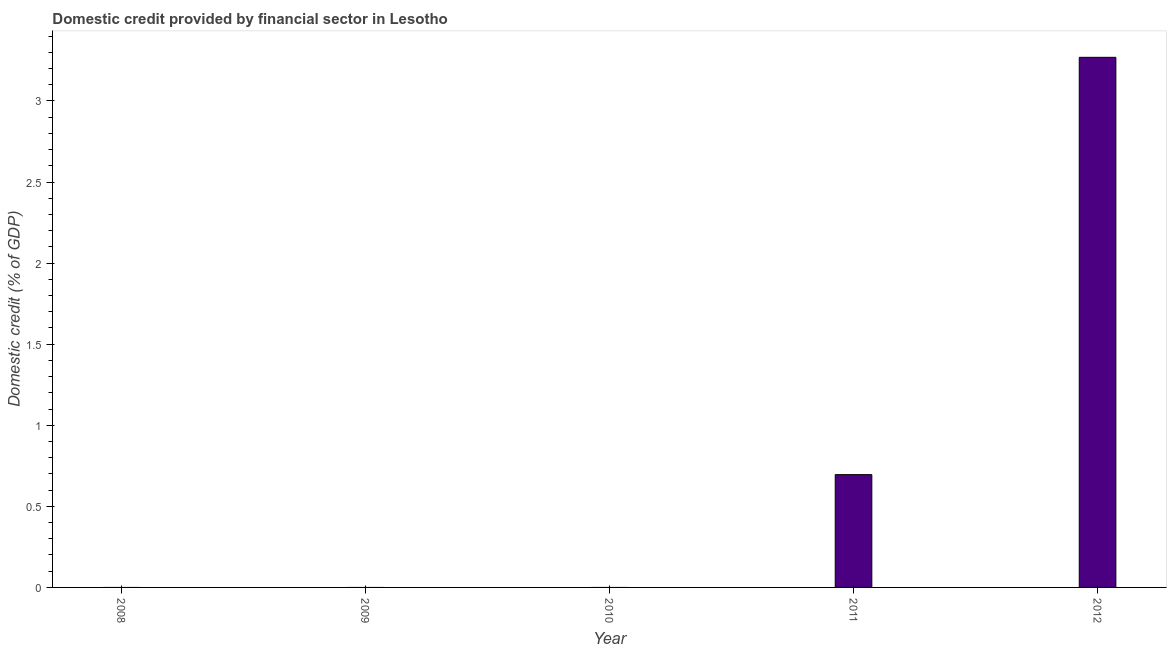Does the graph contain any zero values?
Give a very brief answer. Yes. What is the title of the graph?
Offer a very short reply. Domestic credit provided by financial sector in Lesotho. What is the label or title of the Y-axis?
Provide a short and direct response. Domestic credit (% of GDP). What is the domestic credit provided by financial sector in 2012?
Your answer should be very brief. 3.27. Across all years, what is the maximum domestic credit provided by financial sector?
Make the answer very short. 3.27. Across all years, what is the minimum domestic credit provided by financial sector?
Offer a terse response. 0. In which year was the domestic credit provided by financial sector maximum?
Offer a terse response. 2012. What is the sum of the domestic credit provided by financial sector?
Provide a succinct answer. 3.96. What is the average domestic credit provided by financial sector per year?
Your response must be concise. 0.79. What is the ratio of the domestic credit provided by financial sector in 2011 to that in 2012?
Make the answer very short. 0.21. Is the domestic credit provided by financial sector in 2011 less than that in 2012?
Provide a short and direct response. Yes. What is the difference between the highest and the lowest domestic credit provided by financial sector?
Provide a succinct answer. 3.27. In how many years, is the domestic credit provided by financial sector greater than the average domestic credit provided by financial sector taken over all years?
Provide a short and direct response. 1. How many bars are there?
Provide a short and direct response. 2. Are all the bars in the graph horizontal?
Your answer should be compact. No. What is the difference between two consecutive major ticks on the Y-axis?
Your answer should be very brief. 0.5. What is the Domestic credit (% of GDP) of 2008?
Offer a terse response. 0. What is the Domestic credit (% of GDP) of 2009?
Give a very brief answer. 0. What is the Domestic credit (% of GDP) in 2010?
Offer a very short reply. 0. What is the Domestic credit (% of GDP) in 2011?
Make the answer very short. 0.7. What is the Domestic credit (% of GDP) in 2012?
Provide a succinct answer. 3.27. What is the difference between the Domestic credit (% of GDP) in 2011 and 2012?
Make the answer very short. -2.57. What is the ratio of the Domestic credit (% of GDP) in 2011 to that in 2012?
Offer a terse response. 0.21. 